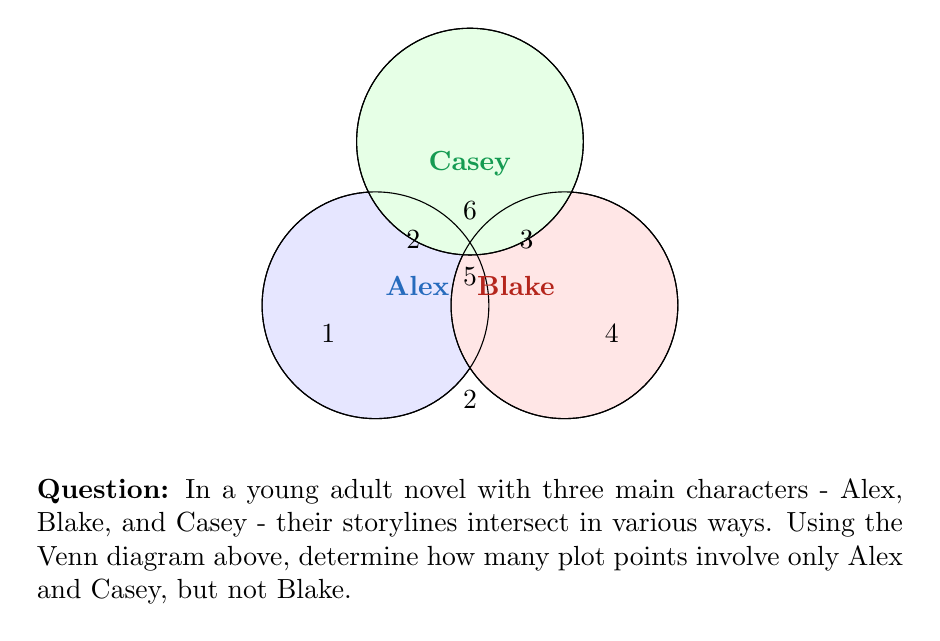Provide a solution to this math problem. To solve this problem, we need to understand how Venn diagrams represent relationships between sets. In this case, each circle represents the plot points involving each character.

1. The region we're interested in is the one that includes only Alex and Casey, but not Blake.

2. In the Venn diagram, this region is represented by the area where Alex's and Casey's circles overlap, but does not include the center where all three circles intersect.

3. Looking at the diagram, we can see that this region is labeled with the number 2.

4. Therefore, there are 2 plot points that involve only Alex and Casey, but not Blake.

This type of analysis can be useful for authors to visualize and keep track of complex character interactions and plot developments in multi-perspective narratives. It helps ensure balanced storytelling and can reveal opportunities for further character development or plot connections.
Answer: 2 